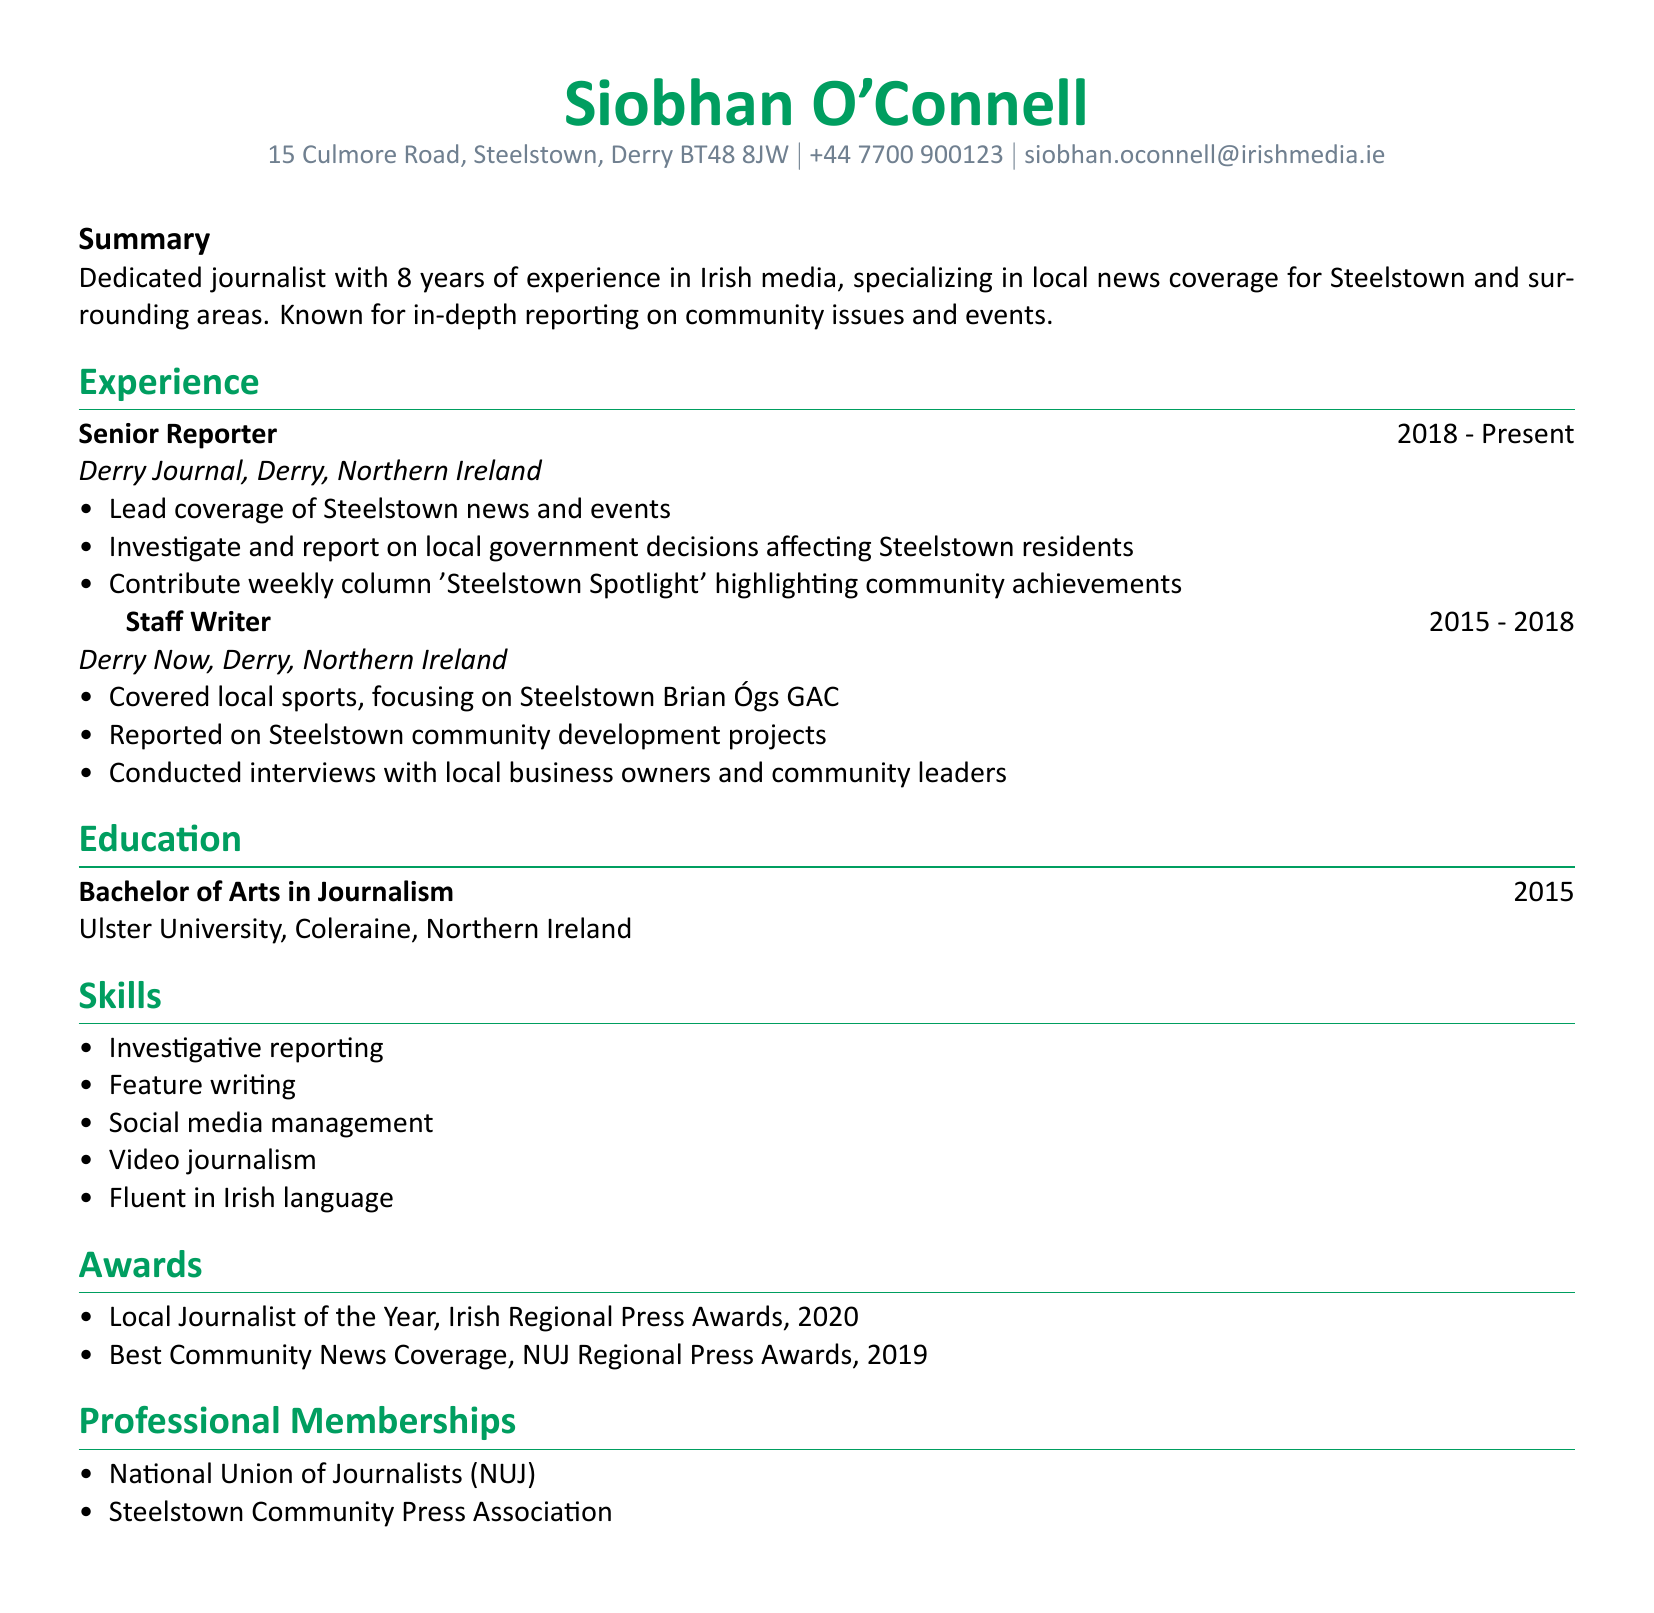what is the name of the journalist? The name is listed at the top of the document as the main subject.
Answer: Siobhan O'Connell what is the email address provided in the CV? The email address can be found in the personal information section of the document.
Answer: siobhan.oconnell@irishmedia.ie what position does Siobhan O'Connell hold at Derry Journal? The position is mentioned in the experience section under her current employment.
Answer: Senior Reporter which award did Siobhan O'Connell win in 2020? The specific award is mentioned in the awards section of the CV.
Answer: Local Journalist of the Year how many years of experience does Siobhan O'Connell have? The total years of experience are summed up in the summary section of the document.
Answer: 8 years what local sports team did Siobhan cover while working at Derry Now? The local sports team is mentioned as part of her responsibilities during her time at Derry Now.
Answer: Steelstown Brian Ógs GAC what is the highest degree Siobhan O'Connell has obtained? The highest educational attainment is listed in the education section of the CV.
Answer: Bachelor of Arts in Journalism what is the focus of the weekly column Siobhan contributes to? The column's focus is outlined in her responsibilities as a Senior Reporter.
Answer: Community achievements which professional membership does Siobhan O'Connell hold? This information is listed in the professional memberships section of the document.
Answer: National Union of Journalists (NUJ) 